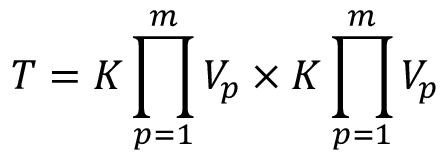<formula> <loc_0><loc_0><loc_500><loc_500>T = K \prod _ { p = 1 } ^ { m } V _ { p } \times K \prod _ { p = 1 } ^ { m } V _ { p }</formula> 